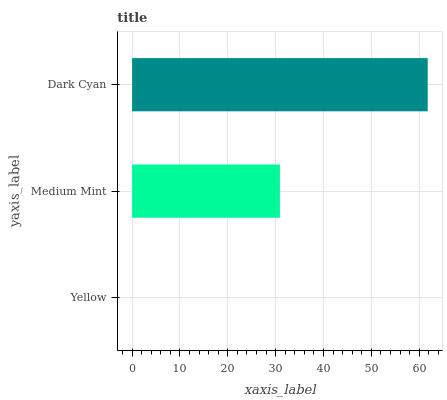Is Yellow the minimum?
Answer yes or no. Yes. Is Dark Cyan the maximum?
Answer yes or no. Yes. Is Medium Mint the minimum?
Answer yes or no. No. Is Medium Mint the maximum?
Answer yes or no. No. Is Medium Mint greater than Yellow?
Answer yes or no. Yes. Is Yellow less than Medium Mint?
Answer yes or no. Yes. Is Yellow greater than Medium Mint?
Answer yes or no. No. Is Medium Mint less than Yellow?
Answer yes or no. No. Is Medium Mint the high median?
Answer yes or no. Yes. Is Medium Mint the low median?
Answer yes or no. Yes. Is Yellow the high median?
Answer yes or no. No. Is Dark Cyan the low median?
Answer yes or no. No. 